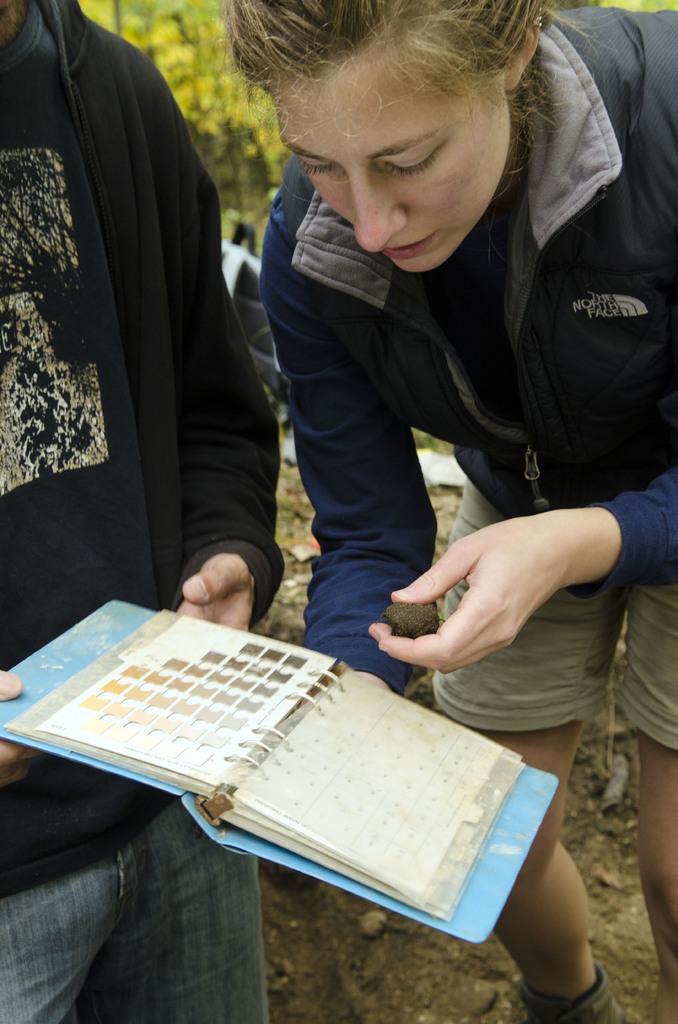Describe this image in one or two sentences. In this picture we can see there are two people standing and a person is holding a book and another person is holding an object. Behind the people there are trees and some objects. 